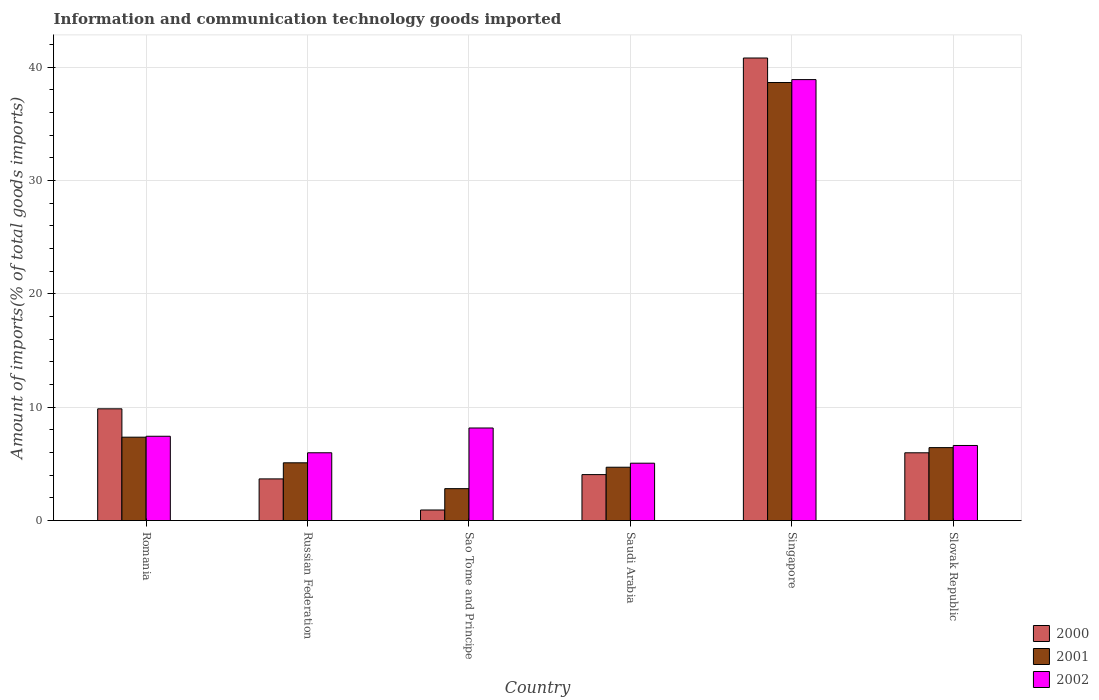How many different coloured bars are there?
Make the answer very short. 3. How many groups of bars are there?
Provide a short and direct response. 6. Are the number of bars per tick equal to the number of legend labels?
Provide a succinct answer. Yes. What is the label of the 2nd group of bars from the left?
Your answer should be very brief. Russian Federation. What is the amount of goods imported in 2002 in Slovak Republic?
Ensure brevity in your answer.  6.63. Across all countries, what is the maximum amount of goods imported in 2000?
Make the answer very short. 40.81. Across all countries, what is the minimum amount of goods imported in 2001?
Give a very brief answer. 2.82. In which country was the amount of goods imported in 2002 maximum?
Give a very brief answer. Singapore. In which country was the amount of goods imported in 2002 minimum?
Provide a short and direct response. Saudi Arabia. What is the total amount of goods imported in 2000 in the graph?
Make the answer very short. 65.31. What is the difference between the amount of goods imported in 2002 in Russian Federation and that in Sao Tome and Principe?
Offer a terse response. -2.19. What is the difference between the amount of goods imported in 2000 in Slovak Republic and the amount of goods imported in 2002 in Singapore?
Offer a very short reply. -32.92. What is the average amount of goods imported in 2002 per country?
Give a very brief answer. 12.03. What is the difference between the amount of goods imported of/in 2000 and amount of goods imported of/in 2001 in Russian Federation?
Provide a short and direct response. -1.42. In how many countries, is the amount of goods imported in 2002 greater than 24 %?
Make the answer very short. 1. What is the ratio of the amount of goods imported in 2002 in Romania to that in Sao Tome and Principe?
Your response must be concise. 0.91. Is the amount of goods imported in 2000 in Romania less than that in Singapore?
Make the answer very short. Yes. Is the difference between the amount of goods imported in 2000 in Sao Tome and Principe and Saudi Arabia greater than the difference between the amount of goods imported in 2001 in Sao Tome and Principe and Saudi Arabia?
Your answer should be compact. No. What is the difference between the highest and the second highest amount of goods imported in 2002?
Your response must be concise. -30.73. What is the difference between the highest and the lowest amount of goods imported in 2002?
Your answer should be very brief. 33.84. In how many countries, is the amount of goods imported in 2002 greater than the average amount of goods imported in 2002 taken over all countries?
Ensure brevity in your answer.  1. Is it the case that in every country, the sum of the amount of goods imported in 2001 and amount of goods imported in 2002 is greater than the amount of goods imported in 2000?
Offer a terse response. Yes. How many countries are there in the graph?
Ensure brevity in your answer.  6. Are the values on the major ticks of Y-axis written in scientific E-notation?
Provide a short and direct response. No. Does the graph contain any zero values?
Your answer should be compact. No. What is the title of the graph?
Your response must be concise. Information and communication technology goods imported. What is the label or title of the X-axis?
Make the answer very short. Country. What is the label or title of the Y-axis?
Provide a succinct answer. Amount of imports(% of total goods imports). What is the Amount of imports(% of total goods imports) of 2000 in Romania?
Offer a terse response. 9.86. What is the Amount of imports(% of total goods imports) of 2001 in Romania?
Your answer should be very brief. 7.36. What is the Amount of imports(% of total goods imports) of 2002 in Romania?
Provide a short and direct response. 7.44. What is the Amount of imports(% of total goods imports) in 2000 in Russian Federation?
Give a very brief answer. 3.68. What is the Amount of imports(% of total goods imports) in 2001 in Russian Federation?
Make the answer very short. 5.1. What is the Amount of imports(% of total goods imports) of 2002 in Russian Federation?
Your response must be concise. 5.98. What is the Amount of imports(% of total goods imports) of 2000 in Sao Tome and Principe?
Provide a succinct answer. 0.93. What is the Amount of imports(% of total goods imports) in 2001 in Sao Tome and Principe?
Provide a short and direct response. 2.82. What is the Amount of imports(% of total goods imports) in 2002 in Sao Tome and Principe?
Ensure brevity in your answer.  8.17. What is the Amount of imports(% of total goods imports) in 2000 in Saudi Arabia?
Ensure brevity in your answer.  4.06. What is the Amount of imports(% of total goods imports) in 2001 in Saudi Arabia?
Ensure brevity in your answer.  4.71. What is the Amount of imports(% of total goods imports) of 2002 in Saudi Arabia?
Provide a succinct answer. 5.06. What is the Amount of imports(% of total goods imports) in 2000 in Singapore?
Give a very brief answer. 40.81. What is the Amount of imports(% of total goods imports) of 2001 in Singapore?
Make the answer very short. 38.64. What is the Amount of imports(% of total goods imports) in 2002 in Singapore?
Ensure brevity in your answer.  38.9. What is the Amount of imports(% of total goods imports) in 2000 in Slovak Republic?
Your answer should be compact. 5.98. What is the Amount of imports(% of total goods imports) of 2001 in Slovak Republic?
Give a very brief answer. 6.44. What is the Amount of imports(% of total goods imports) of 2002 in Slovak Republic?
Your answer should be compact. 6.63. Across all countries, what is the maximum Amount of imports(% of total goods imports) in 2000?
Provide a succinct answer. 40.81. Across all countries, what is the maximum Amount of imports(% of total goods imports) in 2001?
Your answer should be compact. 38.64. Across all countries, what is the maximum Amount of imports(% of total goods imports) of 2002?
Provide a succinct answer. 38.9. Across all countries, what is the minimum Amount of imports(% of total goods imports) in 2000?
Offer a very short reply. 0.93. Across all countries, what is the minimum Amount of imports(% of total goods imports) of 2001?
Offer a very short reply. 2.82. Across all countries, what is the minimum Amount of imports(% of total goods imports) of 2002?
Make the answer very short. 5.06. What is the total Amount of imports(% of total goods imports) in 2000 in the graph?
Offer a very short reply. 65.31. What is the total Amount of imports(% of total goods imports) of 2001 in the graph?
Offer a terse response. 65.06. What is the total Amount of imports(% of total goods imports) in 2002 in the graph?
Provide a short and direct response. 72.18. What is the difference between the Amount of imports(% of total goods imports) in 2000 in Romania and that in Russian Federation?
Offer a terse response. 6.18. What is the difference between the Amount of imports(% of total goods imports) in 2001 in Romania and that in Russian Federation?
Keep it short and to the point. 2.26. What is the difference between the Amount of imports(% of total goods imports) in 2002 in Romania and that in Russian Federation?
Your answer should be very brief. 1.46. What is the difference between the Amount of imports(% of total goods imports) of 2000 in Romania and that in Sao Tome and Principe?
Keep it short and to the point. 8.92. What is the difference between the Amount of imports(% of total goods imports) in 2001 in Romania and that in Sao Tome and Principe?
Provide a succinct answer. 4.54. What is the difference between the Amount of imports(% of total goods imports) of 2002 in Romania and that in Sao Tome and Principe?
Your response must be concise. -0.73. What is the difference between the Amount of imports(% of total goods imports) in 2000 in Romania and that in Saudi Arabia?
Ensure brevity in your answer.  5.8. What is the difference between the Amount of imports(% of total goods imports) in 2001 in Romania and that in Saudi Arabia?
Provide a short and direct response. 2.65. What is the difference between the Amount of imports(% of total goods imports) in 2002 in Romania and that in Saudi Arabia?
Provide a short and direct response. 2.38. What is the difference between the Amount of imports(% of total goods imports) of 2000 in Romania and that in Singapore?
Offer a very short reply. -30.95. What is the difference between the Amount of imports(% of total goods imports) in 2001 in Romania and that in Singapore?
Your answer should be very brief. -31.29. What is the difference between the Amount of imports(% of total goods imports) of 2002 in Romania and that in Singapore?
Provide a succinct answer. -31.46. What is the difference between the Amount of imports(% of total goods imports) of 2000 in Romania and that in Slovak Republic?
Offer a terse response. 3.88. What is the difference between the Amount of imports(% of total goods imports) in 2001 in Romania and that in Slovak Republic?
Provide a short and direct response. 0.92. What is the difference between the Amount of imports(% of total goods imports) of 2002 in Romania and that in Slovak Republic?
Ensure brevity in your answer.  0.81. What is the difference between the Amount of imports(% of total goods imports) in 2000 in Russian Federation and that in Sao Tome and Principe?
Keep it short and to the point. 2.74. What is the difference between the Amount of imports(% of total goods imports) in 2001 in Russian Federation and that in Sao Tome and Principe?
Keep it short and to the point. 2.28. What is the difference between the Amount of imports(% of total goods imports) of 2002 in Russian Federation and that in Sao Tome and Principe?
Offer a very short reply. -2.19. What is the difference between the Amount of imports(% of total goods imports) in 2000 in Russian Federation and that in Saudi Arabia?
Give a very brief answer. -0.38. What is the difference between the Amount of imports(% of total goods imports) of 2001 in Russian Federation and that in Saudi Arabia?
Your answer should be very brief. 0.39. What is the difference between the Amount of imports(% of total goods imports) of 2002 in Russian Federation and that in Saudi Arabia?
Your answer should be compact. 0.92. What is the difference between the Amount of imports(% of total goods imports) in 2000 in Russian Federation and that in Singapore?
Offer a very short reply. -37.13. What is the difference between the Amount of imports(% of total goods imports) in 2001 in Russian Federation and that in Singapore?
Provide a succinct answer. -33.55. What is the difference between the Amount of imports(% of total goods imports) in 2002 in Russian Federation and that in Singapore?
Your response must be concise. -32.92. What is the difference between the Amount of imports(% of total goods imports) of 2000 in Russian Federation and that in Slovak Republic?
Make the answer very short. -2.3. What is the difference between the Amount of imports(% of total goods imports) of 2001 in Russian Federation and that in Slovak Republic?
Give a very brief answer. -1.34. What is the difference between the Amount of imports(% of total goods imports) in 2002 in Russian Federation and that in Slovak Republic?
Make the answer very short. -0.64. What is the difference between the Amount of imports(% of total goods imports) of 2000 in Sao Tome and Principe and that in Saudi Arabia?
Keep it short and to the point. -3.12. What is the difference between the Amount of imports(% of total goods imports) in 2001 in Sao Tome and Principe and that in Saudi Arabia?
Make the answer very short. -1.89. What is the difference between the Amount of imports(% of total goods imports) in 2002 in Sao Tome and Principe and that in Saudi Arabia?
Keep it short and to the point. 3.11. What is the difference between the Amount of imports(% of total goods imports) in 2000 in Sao Tome and Principe and that in Singapore?
Your response must be concise. -39.87. What is the difference between the Amount of imports(% of total goods imports) of 2001 in Sao Tome and Principe and that in Singapore?
Give a very brief answer. -35.83. What is the difference between the Amount of imports(% of total goods imports) in 2002 in Sao Tome and Principe and that in Singapore?
Ensure brevity in your answer.  -30.73. What is the difference between the Amount of imports(% of total goods imports) in 2000 in Sao Tome and Principe and that in Slovak Republic?
Make the answer very short. -5.05. What is the difference between the Amount of imports(% of total goods imports) in 2001 in Sao Tome and Principe and that in Slovak Republic?
Keep it short and to the point. -3.62. What is the difference between the Amount of imports(% of total goods imports) of 2002 in Sao Tome and Principe and that in Slovak Republic?
Your response must be concise. 1.54. What is the difference between the Amount of imports(% of total goods imports) of 2000 in Saudi Arabia and that in Singapore?
Your response must be concise. -36.75. What is the difference between the Amount of imports(% of total goods imports) in 2001 in Saudi Arabia and that in Singapore?
Provide a succinct answer. -33.94. What is the difference between the Amount of imports(% of total goods imports) of 2002 in Saudi Arabia and that in Singapore?
Your response must be concise. -33.84. What is the difference between the Amount of imports(% of total goods imports) in 2000 in Saudi Arabia and that in Slovak Republic?
Your response must be concise. -1.92. What is the difference between the Amount of imports(% of total goods imports) in 2001 in Saudi Arabia and that in Slovak Republic?
Ensure brevity in your answer.  -1.73. What is the difference between the Amount of imports(% of total goods imports) in 2002 in Saudi Arabia and that in Slovak Republic?
Your answer should be compact. -1.56. What is the difference between the Amount of imports(% of total goods imports) of 2000 in Singapore and that in Slovak Republic?
Offer a terse response. 34.83. What is the difference between the Amount of imports(% of total goods imports) of 2001 in Singapore and that in Slovak Republic?
Ensure brevity in your answer.  32.21. What is the difference between the Amount of imports(% of total goods imports) in 2002 in Singapore and that in Slovak Republic?
Your response must be concise. 32.28. What is the difference between the Amount of imports(% of total goods imports) of 2000 in Romania and the Amount of imports(% of total goods imports) of 2001 in Russian Federation?
Make the answer very short. 4.76. What is the difference between the Amount of imports(% of total goods imports) of 2000 in Romania and the Amount of imports(% of total goods imports) of 2002 in Russian Federation?
Provide a succinct answer. 3.88. What is the difference between the Amount of imports(% of total goods imports) of 2001 in Romania and the Amount of imports(% of total goods imports) of 2002 in Russian Federation?
Your answer should be compact. 1.37. What is the difference between the Amount of imports(% of total goods imports) in 2000 in Romania and the Amount of imports(% of total goods imports) in 2001 in Sao Tome and Principe?
Make the answer very short. 7.04. What is the difference between the Amount of imports(% of total goods imports) in 2000 in Romania and the Amount of imports(% of total goods imports) in 2002 in Sao Tome and Principe?
Your answer should be compact. 1.69. What is the difference between the Amount of imports(% of total goods imports) of 2001 in Romania and the Amount of imports(% of total goods imports) of 2002 in Sao Tome and Principe?
Your answer should be very brief. -0.81. What is the difference between the Amount of imports(% of total goods imports) in 2000 in Romania and the Amount of imports(% of total goods imports) in 2001 in Saudi Arabia?
Your answer should be very brief. 5.15. What is the difference between the Amount of imports(% of total goods imports) of 2000 in Romania and the Amount of imports(% of total goods imports) of 2002 in Saudi Arabia?
Offer a very short reply. 4.8. What is the difference between the Amount of imports(% of total goods imports) of 2001 in Romania and the Amount of imports(% of total goods imports) of 2002 in Saudi Arabia?
Offer a very short reply. 2.29. What is the difference between the Amount of imports(% of total goods imports) in 2000 in Romania and the Amount of imports(% of total goods imports) in 2001 in Singapore?
Make the answer very short. -28.79. What is the difference between the Amount of imports(% of total goods imports) of 2000 in Romania and the Amount of imports(% of total goods imports) of 2002 in Singapore?
Keep it short and to the point. -29.04. What is the difference between the Amount of imports(% of total goods imports) of 2001 in Romania and the Amount of imports(% of total goods imports) of 2002 in Singapore?
Provide a short and direct response. -31.54. What is the difference between the Amount of imports(% of total goods imports) of 2000 in Romania and the Amount of imports(% of total goods imports) of 2001 in Slovak Republic?
Ensure brevity in your answer.  3.42. What is the difference between the Amount of imports(% of total goods imports) of 2000 in Romania and the Amount of imports(% of total goods imports) of 2002 in Slovak Republic?
Make the answer very short. 3.23. What is the difference between the Amount of imports(% of total goods imports) in 2001 in Romania and the Amount of imports(% of total goods imports) in 2002 in Slovak Republic?
Give a very brief answer. 0.73. What is the difference between the Amount of imports(% of total goods imports) in 2000 in Russian Federation and the Amount of imports(% of total goods imports) in 2001 in Sao Tome and Principe?
Offer a terse response. 0.86. What is the difference between the Amount of imports(% of total goods imports) of 2000 in Russian Federation and the Amount of imports(% of total goods imports) of 2002 in Sao Tome and Principe?
Give a very brief answer. -4.49. What is the difference between the Amount of imports(% of total goods imports) of 2001 in Russian Federation and the Amount of imports(% of total goods imports) of 2002 in Sao Tome and Principe?
Provide a succinct answer. -3.07. What is the difference between the Amount of imports(% of total goods imports) in 2000 in Russian Federation and the Amount of imports(% of total goods imports) in 2001 in Saudi Arabia?
Provide a short and direct response. -1.03. What is the difference between the Amount of imports(% of total goods imports) in 2000 in Russian Federation and the Amount of imports(% of total goods imports) in 2002 in Saudi Arabia?
Provide a short and direct response. -1.38. What is the difference between the Amount of imports(% of total goods imports) of 2001 in Russian Federation and the Amount of imports(% of total goods imports) of 2002 in Saudi Arabia?
Your answer should be very brief. 0.04. What is the difference between the Amount of imports(% of total goods imports) in 2000 in Russian Federation and the Amount of imports(% of total goods imports) in 2001 in Singapore?
Your response must be concise. -34.97. What is the difference between the Amount of imports(% of total goods imports) in 2000 in Russian Federation and the Amount of imports(% of total goods imports) in 2002 in Singapore?
Give a very brief answer. -35.22. What is the difference between the Amount of imports(% of total goods imports) in 2001 in Russian Federation and the Amount of imports(% of total goods imports) in 2002 in Singapore?
Provide a succinct answer. -33.8. What is the difference between the Amount of imports(% of total goods imports) in 2000 in Russian Federation and the Amount of imports(% of total goods imports) in 2001 in Slovak Republic?
Offer a very short reply. -2.76. What is the difference between the Amount of imports(% of total goods imports) in 2000 in Russian Federation and the Amount of imports(% of total goods imports) in 2002 in Slovak Republic?
Provide a short and direct response. -2.95. What is the difference between the Amount of imports(% of total goods imports) of 2001 in Russian Federation and the Amount of imports(% of total goods imports) of 2002 in Slovak Republic?
Keep it short and to the point. -1.53. What is the difference between the Amount of imports(% of total goods imports) in 2000 in Sao Tome and Principe and the Amount of imports(% of total goods imports) in 2001 in Saudi Arabia?
Your answer should be very brief. -3.77. What is the difference between the Amount of imports(% of total goods imports) in 2000 in Sao Tome and Principe and the Amount of imports(% of total goods imports) in 2002 in Saudi Arabia?
Your answer should be compact. -4.13. What is the difference between the Amount of imports(% of total goods imports) in 2001 in Sao Tome and Principe and the Amount of imports(% of total goods imports) in 2002 in Saudi Arabia?
Your answer should be compact. -2.24. What is the difference between the Amount of imports(% of total goods imports) in 2000 in Sao Tome and Principe and the Amount of imports(% of total goods imports) in 2001 in Singapore?
Make the answer very short. -37.71. What is the difference between the Amount of imports(% of total goods imports) of 2000 in Sao Tome and Principe and the Amount of imports(% of total goods imports) of 2002 in Singapore?
Offer a terse response. -37.97. What is the difference between the Amount of imports(% of total goods imports) in 2001 in Sao Tome and Principe and the Amount of imports(% of total goods imports) in 2002 in Singapore?
Give a very brief answer. -36.08. What is the difference between the Amount of imports(% of total goods imports) of 2000 in Sao Tome and Principe and the Amount of imports(% of total goods imports) of 2001 in Slovak Republic?
Provide a short and direct response. -5.5. What is the difference between the Amount of imports(% of total goods imports) in 2000 in Sao Tome and Principe and the Amount of imports(% of total goods imports) in 2002 in Slovak Republic?
Keep it short and to the point. -5.69. What is the difference between the Amount of imports(% of total goods imports) in 2001 in Sao Tome and Principe and the Amount of imports(% of total goods imports) in 2002 in Slovak Republic?
Give a very brief answer. -3.81. What is the difference between the Amount of imports(% of total goods imports) of 2000 in Saudi Arabia and the Amount of imports(% of total goods imports) of 2001 in Singapore?
Your answer should be very brief. -34.59. What is the difference between the Amount of imports(% of total goods imports) of 2000 in Saudi Arabia and the Amount of imports(% of total goods imports) of 2002 in Singapore?
Keep it short and to the point. -34.85. What is the difference between the Amount of imports(% of total goods imports) in 2001 in Saudi Arabia and the Amount of imports(% of total goods imports) in 2002 in Singapore?
Provide a succinct answer. -34.19. What is the difference between the Amount of imports(% of total goods imports) in 2000 in Saudi Arabia and the Amount of imports(% of total goods imports) in 2001 in Slovak Republic?
Offer a very short reply. -2.38. What is the difference between the Amount of imports(% of total goods imports) in 2000 in Saudi Arabia and the Amount of imports(% of total goods imports) in 2002 in Slovak Republic?
Ensure brevity in your answer.  -2.57. What is the difference between the Amount of imports(% of total goods imports) in 2001 in Saudi Arabia and the Amount of imports(% of total goods imports) in 2002 in Slovak Republic?
Offer a terse response. -1.92. What is the difference between the Amount of imports(% of total goods imports) in 2000 in Singapore and the Amount of imports(% of total goods imports) in 2001 in Slovak Republic?
Your response must be concise. 34.37. What is the difference between the Amount of imports(% of total goods imports) of 2000 in Singapore and the Amount of imports(% of total goods imports) of 2002 in Slovak Republic?
Provide a short and direct response. 34.18. What is the difference between the Amount of imports(% of total goods imports) of 2001 in Singapore and the Amount of imports(% of total goods imports) of 2002 in Slovak Republic?
Offer a very short reply. 32.02. What is the average Amount of imports(% of total goods imports) of 2000 per country?
Your answer should be compact. 10.89. What is the average Amount of imports(% of total goods imports) in 2001 per country?
Keep it short and to the point. 10.84. What is the average Amount of imports(% of total goods imports) in 2002 per country?
Make the answer very short. 12.03. What is the difference between the Amount of imports(% of total goods imports) of 2000 and Amount of imports(% of total goods imports) of 2001 in Romania?
Provide a short and direct response. 2.5. What is the difference between the Amount of imports(% of total goods imports) of 2000 and Amount of imports(% of total goods imports) of 2002 in Romania?
Provide a short and direct response. 2.42. What is the difference between the Amount of imports(% of total goods imports) of 2001 and Amount of imports(% of total goods imports) of 2002 in Romania?
Keep it short and to the point. -0.08. What is the difference between the Amount of imports(% of total goods imports) in 2000 and Amount of imports(% of total goods imports) in 2001 in Russian Federation?
Give a very brief answer. -1.42. What is the difference between the Amount of imports(% of total goods imports) of 2000 and Amount of imports(% of total goods imports) of 2002 in Russian Federation?
Your response must be concise. -2.3. What is the difference between the Amount of imports(% of total goods imports) in 2001 and Amount of imports(% of total goods imports) in 2002 in Russian Federation?
Offer a very short reply. -0.89. What is the difference between the Amount of imports(% of total goods imports) of 2000 and Amount of imports(% of total goods imports) of 2001 in Sao Tome and Principe?
Make the answer very short. -1.88. What is the difference between the Amount of imports(% of total goods imports) in 2000 and Amount of imports(% of total goods imports) in 2002 in Sao Tome and Principe?
Ensure brevity in your answer.  -7.23. What is the difference between the Amount of imports(% of total goods imports) in 2001 and Amount of imports(% of total goods imports) in 2002 in Sao Tome and Principe?
Keep it short and to the point. -5.35. What is the difference between the Amount of imports(% of total goods imports) in 2000 and Amount of imports(% of total goods imports) in 2001 in Saudi Arabia?
Your answer should be very brief. -0.65. What is the difference between the Amount of imports(% of total goods imports) of 2000 and Amount of imports(% of total goods imports) of 2002 in Saudi Arabia?
Provide a succinct answer. -1.01. What is the difference between the Amount of imports(% of total goods imports) in 2001 and Amount of imports(% of total goods imports) in 2002 in Saudi Arabia?
Offer a very short reply. -0.36. What is the difference between the Amount of imports(% of total goods imports) in 2000 and Amount of imports(% of total goods imports) in 2001 in Singapore?
Your answer should be very brief. 2.16. What is the difference between the Amount of imports(% of total goods imports) in 2000 and Amount of imports(% of total goods imports) in 2002 in Singapore?
Give a very brief answer. 1.9. What is the difference between the Amount of imports(% of total goods imports) of 2001 and Amount of imports(% of total goods imports) of 2002 in Singapore?
Provide a short and direct response. -0.26. What is the difference between the Amount of imports(% of total goods imports) of 2000 and Amount of imports(% of total goods imports) of 2001 in Slovak Republic?
Offer a terse response. -0.46. What is the difference between the Amount of imports(% of total goods imports) of 2000 and Amount of imports(% of total goods imports) of 2002 in Slovak Republic?
Give a very brief answer. -0.65. What is the difference between the Amount of imports(% of total goods imports) in 2001 and Amount of imports(% of total goods imports) in 2002 in Slovak Republic?
Give a very brief answer. -0.19. What is the ratio of the Amount of imports(% of total goods imports) in 2000 in Romania to that in Russian Federation?
Provide a succinct answer. 2.68. What is the ratio of the Amount of imports(% of total goods imports) in 2001 in Romania to that in Russian Federation?
Give a very brief answer. 1.44. What is the ratio of the Amount of imports(% of total goods imports) of 2002 in Romania to that in Russian Federation?
Offer a very short reply. 1.24. What is the ratio of the Amount of imports(% of total goods imports) in 2000 in Romania to that in Sao Tome and Principe?
Ensure brevity in your answer.  10.56. What is the ratio of the Amount of imports(% of total goods imports) of 2001 in Romania to that in Sao Tome and Principe?
Provide a succinct answer. 2.61. What is the ratio of the Amount of imports(% of total goods imports) of 2002 in Romania to that in Sao Tome and Principe?
Give a very brief answer. 0.91. What is the ratio of the Amount of imports(% of total goods imports) in 2000 in Romania to that in Saudi Arabia?
Offer a terse response. 2.43. What is the ratio of the Amount of imports(% of total goods imports) of 2001 in Romania to that in Saudi Arabia?
Ensure brevity in your answer.  1.56. What is the ratio of the Amount of imports(% of total goods imports) in 2002 in Romania to that in Saudi Arabia?
Your answer should be very brief. 1.47. What is the ratio of the Amount of imports(% of total goods imports) in 2000 in Romania to that in Singapore?
Your answer should be very brief. 0.24. What is the ratio of the Amount of imports(% of total goods imports) in 2001 in Romania to that in Singapore?
Offer a terse response. 0.19. What is the ratio of the Amount of imports(% of total goods imports) in 2002 in Romania to that in Singapore?
Give a very brief answer. 0.19. What is the ratio of the Amount of imports(% of total goods imports) in 2000 in Romania to that in Slovak Republic?
Provide a succinct answer. 1.65. What is the ratio of the Amount of imports(% of total goods imports) of 2001 in Romania to that in Slovak Republic?
Provide a succinct answer. 1.14. What is the ratio of the Amount of imports(% of total goods imports) of 2002 in Romania to that in Slovak Republic?
Give a very brief answer. 1.12. What is the ratio of the Amount of imports(% of total goods imports) of 2000 in Russian Federation to that in Sao Tome and Principe?
Your answer should be very brief. 3.94. What is the ratio of the Amount of imports(% of total goods imports) of 2001 in Russian Federation to that in Sao Tome and Principe?
Make the answer very short. 1.81. What is the ratio of the Amount of imports(% of total goods imports) in 2002 in Russian Federation to that in Sao Tome and Principe?
Your answer should be compact. 0.73. What is the ratio of the Amount of imports(% of total goods imports) of 2000 in Russian Federation to that in Saudi Arabia?
Your answer should be compact. 0.91. What is the ratio of the Amount of imports(% of total goods imports) in 2001 in Russian Federation to that in Saudi Arabia?
Your answer should be compact. 1.08. What is the ratio of the Amount of imports(% of total goods imports) of 2002 in Russian Federation to that in Saudi Arabia?
Offer a very short reply. 1.18. What is the ratio of the Amount of imports(% of total goods imports) in 2000 in Russian Federation to that in Singapore?
Your answer should be very brief. 0.09. What is the ratio of the Amount of imports(% of total goods imports) in 2001 in Russian Federation to that in Singapore?
Keep it short and to the point. 0.13. What is the ratio of the Amount of imports(% of total goods imports) of 2002 in Russian Federation to that in Singapore?
Make the answer very short. 0.15. What is the ratio of the Amount of imports(% of total goods imports) of 2000 in Russian Federation to that in Slovak Republic?
Your response must be concise. 0.61. What is the ratio of the Amount of imports(% of total goods imports) of 2001 in Russian Federation to that in Slovak Republic?
Give a very brief answer. 0.79. What is the ratio of the Amount of imports(% of total goods imports) of 2002 in Russian Federation to that in Slovak Republic?
Provide a succinct answer. 0.9. What is the ratio of the Amount of imports(% of total goods imports) in 2000 in Sao Tome and Principe to that in Saudi Arabia?
Make the answer very short. 0.23. What is the ratio of the Amount of imports(% of total goods imports) in 2001 in Sao Tome and Principe to that in Saudi Arabia?
Your answer should be very brief. 0.6. What is the ratio of the Amount of imports(% of total goods imports) in 2002 in Sao Tome and Principe to that in Saudi Arabia?
Give a very brief answer. 1.61. What is the ratio of the Amount of imports(% of total goods imports) in 2000 in Sao Tome and Principe to that in Singapore?
Give a very brief answer. 0.02. What is the ratio of the Amount of imports(% of total goods imports) of 2001 in Sao Tome and Principe to that in Singapore?
Offer a very short reply. 0.07. What is the ratio of the Amount of imports(% of total goods imports) of 2002 in Sao Tome and Principe to that in Singapore?
Make the answer very short. 0.21. What is the ratio of the Amount of imports(% of total goods imports) of 2000 in Sao Tome and Principe to that in Slovak Republic?
Ensure brevity in your answer.  0.16. What is the ratio of the Amount of imports(% of total goods imports) of 2001 in Sao Tome and Principe to that in Slovak Republic?
Keep it short and to the point. 0.44. What is the ratio of the Amount of imports(% of total goods imports) of 2002 in Sao Tome and Principe to that in Slovak Republic?
Your answer should be compact. 1.23. What is the ratio of the Amount of imports(% of total goods imports) of 2000 in Saudi Arabia to that in Singapore?
Offer a very short reply. 0.1. What is the ratio of the Amount of imports(% of total goods imports) of 2001 in Saudi Arabia to that in Singapore?
Your answer should be compact. 0.12. What is the ratio of the Amount of imports(% of total goods imports) in 2002 in Saudi Arabia to that in Singapore?
Provide a short and direct response. 0.13. What is the ratio of the Amount of imports(% of total goods imports) in 2000 in Saudi Arabia to that in Slovak Republic?
Give a very brief answer. 0.68. What is the ratio of the Amount of imports(% of total goods imports) in 2001 in Saudi Arabia to that in Slovak Republic?
Offer a very short reply. 0.73. What is the ratio of the Amount of imports(% of total goods imports) in 2002 in Saudi Arabia to that in Slovak Republic?
Offer a terse response. 0.76. What is the ratio of the Amount of imports(% of total goods imports) in 2000 in Singapore to that in Slovak Republic?
Offer a very short reply. 6.82. What is the ratio of the Amount of imports(% of total goods imports) of 2001 in Singapore to that in Slovak Republic?
Your answer should be compact. 6. What is the ratio of the Amount of imports(% of total goods imports) in 2002 in Singapore to that in Slovak Republic?
Your answer should be very brief. 5.87. What is the difference between the highest and the second highest Amount of imports(% of total goods imports) in 2000?
Offer a terse response. 30.95. What is the difference between the highest and the second highest Amount of imports(% of total goods imports) in 2001?
Your answer should be compact. 31.29. What is the difference between the highest and the second highest Amount of imports(% of total goods imports) of 2002?
Your answer should be very brief. 30.73. What is the difference between the highest and the lowest Amount of imports(% of total goods imports) of 2000?
Your answer should be very brief. 39.87. What is the difference between the highest and the lowest Amount of imports(% of total goods imports) of 2001?
Give a very brief answer. 35.83. What is the difference between the highest and the lowest Amount of imports(% of total goods imports) in 2002?
Provide a short and direct response. 33.84. 